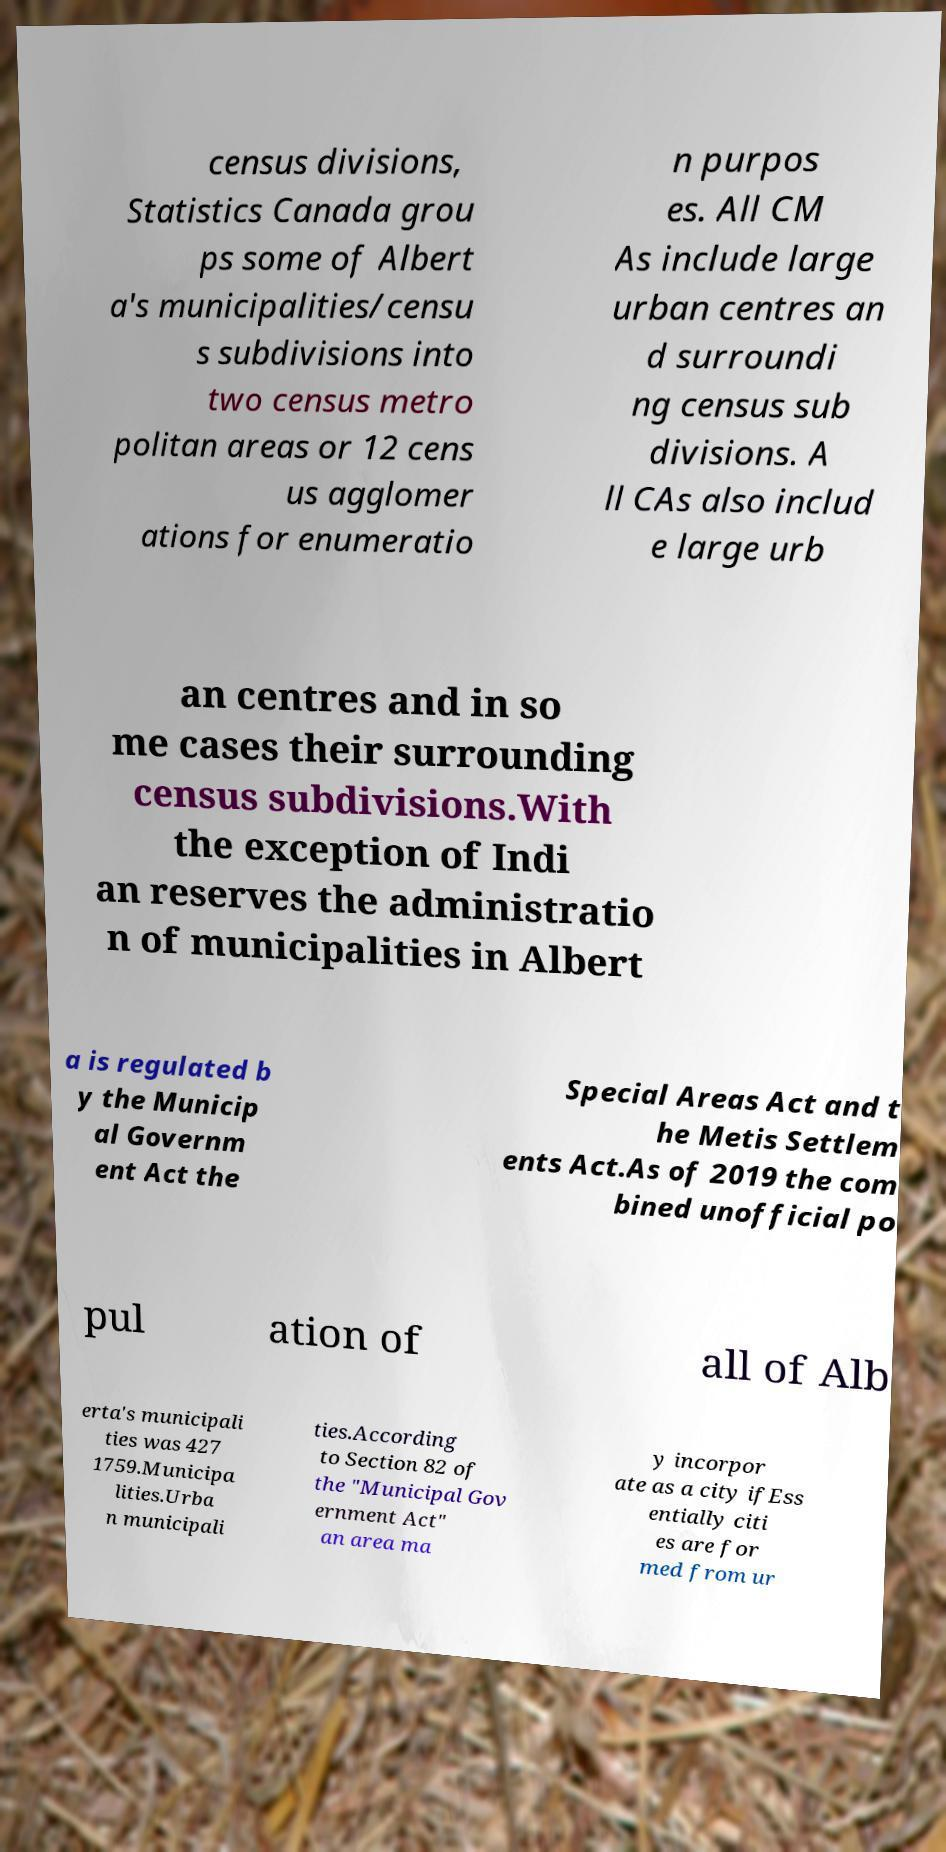For documentation purposes, I need the text within this image transcribed. Could you provide that? census divisions, Statistics Canada grou ps some of Albert a's municipalities/censu s subdivisions into two census metro politan areas or 12 cens us agglomer ations for enumeratio n purpos es. All CM As include large urban centres an d surroundi ng census sub divisions. A ll CAs also includ e large urb an centres and in so me cases their surrounding census subdivisions.With the exception of Indi an reserves the administratio n of municipalities in Albert a is regulated b y the Municip al Governm ent Act the Special Areas Act and t he Metis Settlem ents Act.As of 2019 the com bined unofficial po pul ation of all of Alb erta's municipali ties was 427 1759.Municipa lities.Urba n municipali ties.According to Section 82 of the "Municipal Gov ernment Act" an area ma y incorpor ate as a city ifEss entially citi es are for med from ur 